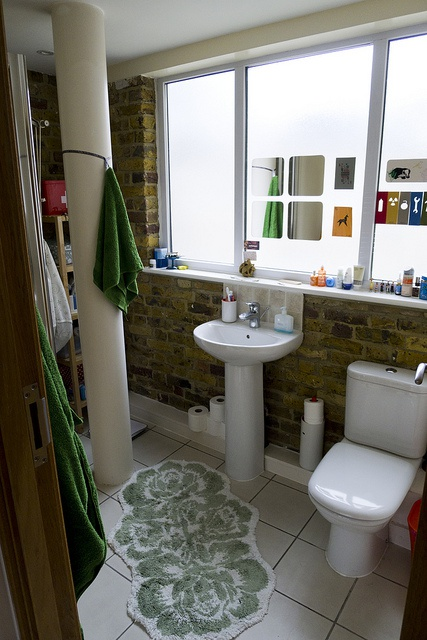Describe the objects in this image and their specific colors. I can see toilet in black, gray, darkgray, and lightgray tones, sink in black, gray, darkgray, and lavender tones, bottle in black, darkgray, and gray tones, cup in black, darkgray, and gray tones, and bottle in black, white, and tan tones in this image. 